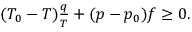<formula> <loc_0><loc_0><loc_500><loc_500>\begin{array} { r } { ( T _ { 0 } - T ) \frac { q } { T } + ( p - p _ { 0 } ) f \geq 0 . } \end{array}</formula> 